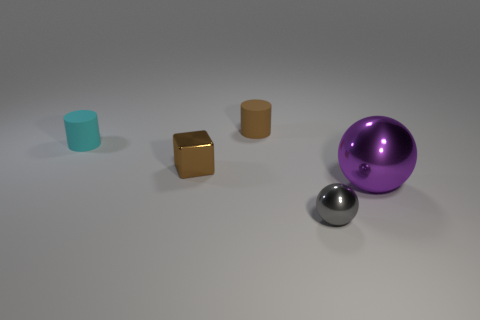Does the small thing that is in front of the large purple shiny thing have the same shape as the metallic thing that is to the right of the gray thing?
Ensure brevity in your answer.  Yes. What number of other objects are there of the same material as the tiny cube?
Provide a short and direct response. 2. Do the cylinder that is to the left of the brown matte thing and the thing to the right of the gray metallic thing have the same material?
Provide a short and direct response. No. There is a gray thing that is made of the same material as the small brown cube; what shape is it?
Provide a succinct answer. Sphere. Is there any other thing of the same color as the tiny metallic sphere?
Provide a short and direct response. No. What number of small green cubes are there?
Your answer should be compact. 0. There is a metallic object that is left of the big purple shiny thing and in front of the brown block; what is its shape?
Provide a short and direct response. Sphere. There is a small matte thing that is on the left side of the matte object behind the small cylinder in front of the tiny brown matte thing; what shape is it?
Your answer should be very brief. Cylinder. The thing that is in front of the tiny cyan cylinder and behind the purple metal sphere is made of what material?
Ensure brevity in your answer.  Metal. How many brown matte objects are the same size as the gray shiny object?
Your answer should be compact. 1. 